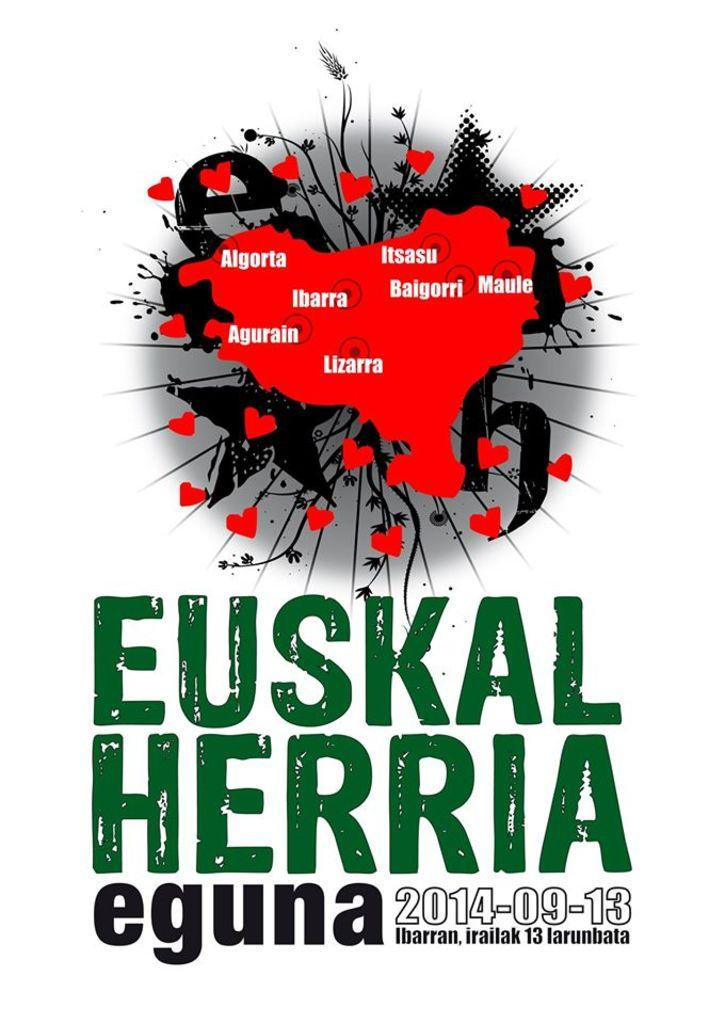What is present on the poster in the image? There is a poster in the image, and it has a map on it. What colors are used for the text on the poster? The text on the poster is in green and black colors. What can be found on the map? The map has location names on it. What is the color of the background in the image? The background of the image is white. How many tents are set up in the image? There are no tents present in the image. 